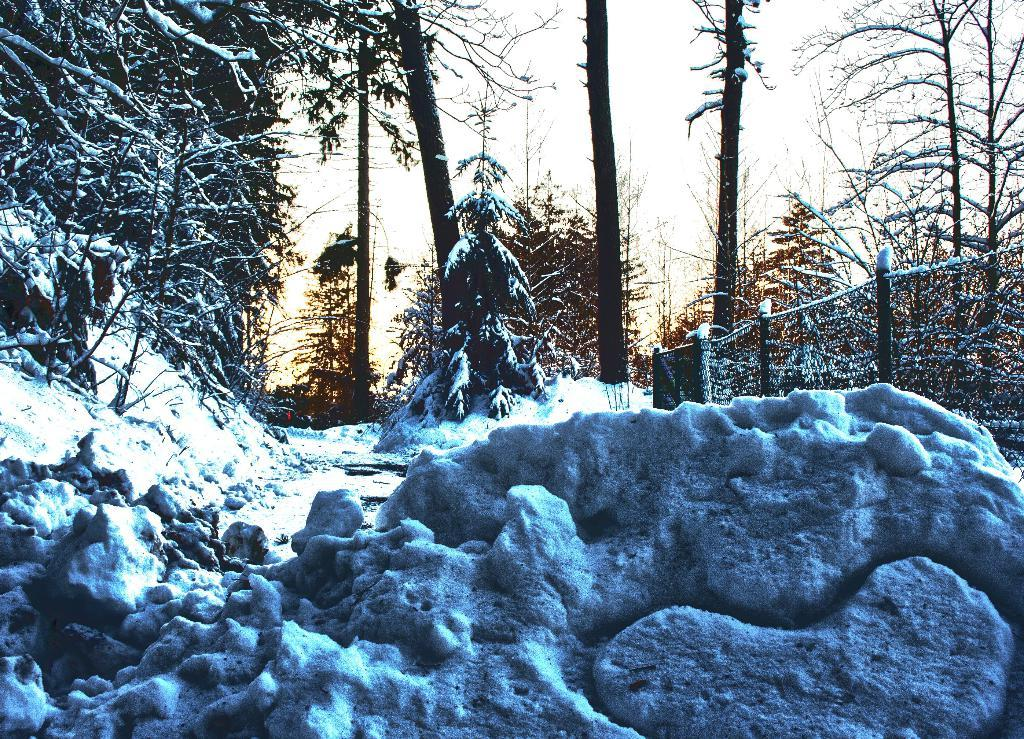What type of barrier can be seen in the image? There is a fence in the image. What natural elements are present in the image? There are trees in the image. What weather condition is depicted in the image? There is snow visible in the image. Can you see a giraffe interacting with the snow in the image? There is no giraffe present in the image; it features a fence and trees with snow. What type of soap is used to clean the fence in the image? There is no soap or cleaning activity depicted in the image; it only shows a fence, trees, and snow. 